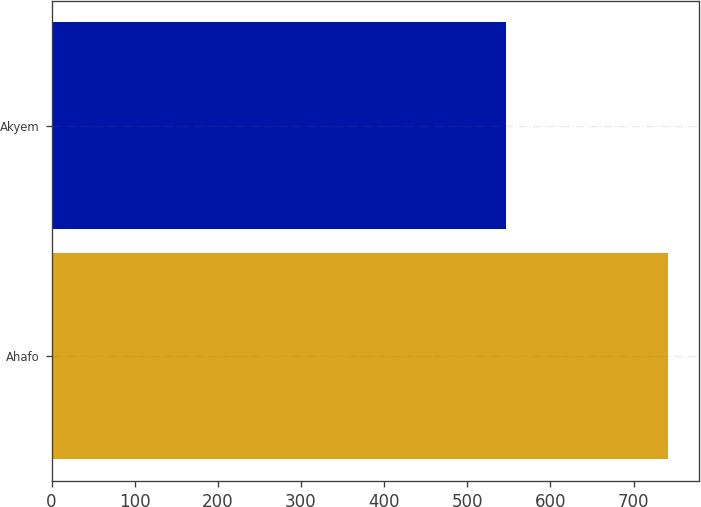Convert chart to OTSL. <chart><loc_0><loc_0><loc_500><loc_500><bar_chart><fcel>Ahafo<fcel>Akyem<nl><fcel>741<fcel>546<nl></chart> 